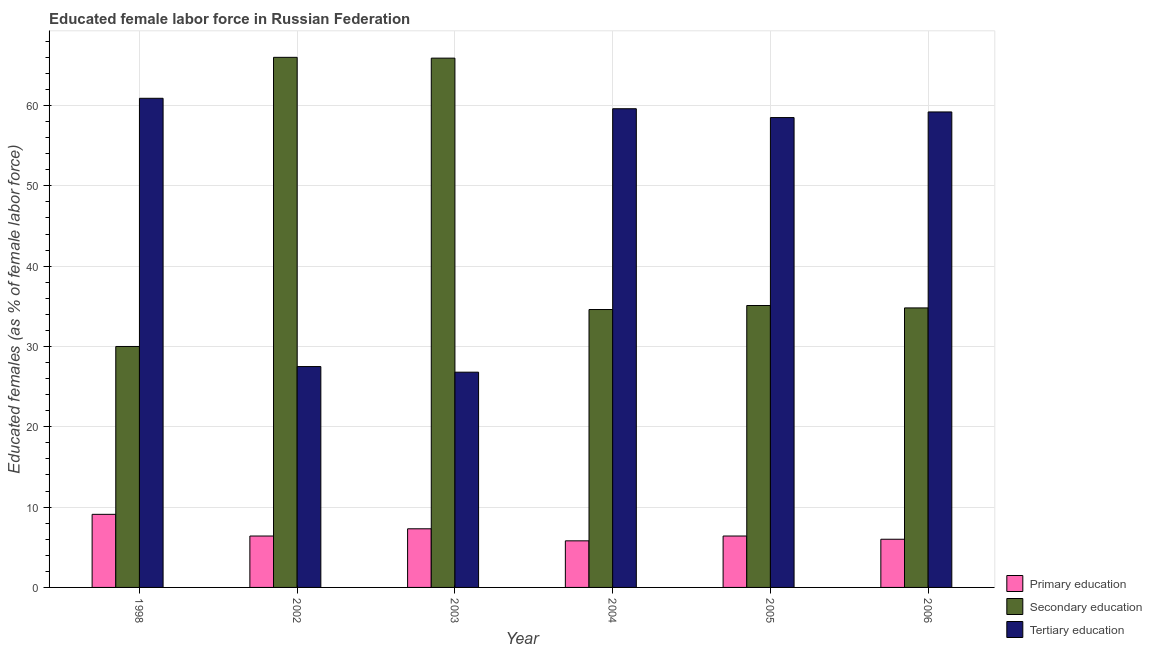How many groups of bars are there?
Make the answer very short. 6. Are the number of bars on each tick of the X-axis equal?
Keep it short and to the point. Yes. How many bars are there on the 4th tick from the left?
Make the answer very short. 3. What is the label of the 3rd group of bars from the left?
Your answer should be very brief. 2003. In how many cases, is the number of bars for a given year not equal to the number of legend labels?
Your response must be concise. 0. What is the percentage of female labor force who received primary education in 2006?
Offer a terse response. 6. Across all years, what is the maximum percentage of female labor force who received secondary education?
Provide a short and direct response. 66. In which year was the percentage of female labor force who received secondary education maximum?
Provide a succinct answer. 2002. What is the total percentage of female labor force who received secondary education in the graph?
Provide a succinct answer. 266.4. What is the difference between the percentage of female labor force who received tertiary education in 2006 and the percentage of female labor force who received secondary education in 2003?
Ensure brevity in your answer.  32.4. What is the average percentage of female labor force who received primary education per year?
Offer a very short reply. 6.83. What is the ratio of the percentage of female labor force who received secondary education in 2003 to that in 2006?
Offer a very short reply. 1.89. Is the percentage of female labor force who received secondary education in 1998 less than that in 2004?
Keep it short and to the point. Yes. What is the difference between the highest and the second highest percentage of female labor force who received primary education?
Give a very brief answer. 1.8. What is the difference between the highest and the lowest percentage of female labor force who received secondary education?
Keep it short and to the point. 36. What does the 3rd bar from the left in 2004 represents?
Keep it short and to the point. Tertiary education. What does the 1st bar from the right in 2006 represents?
Keep it short and to the point. Tertiary education. Is it the case that in every year, the sum of the percentage of female labor force who received primary education and percentage of female labor force who received secondary education is greater than the percentage of female labor force who received tertiary education?
Provide a short and direct response. No. How many bars are there?
Provide a short and direct response. 18. Are all the bars in the graph horizontal?
Provide a short and direct response. No. How many years are there in the graph?
Your answer should be very brief. 6. Does the graph contain grids?
Keep it short and to the point. Yes. Where does the legend appear in the graph?
Give a very brief answer. Bottom right. How are the legend labels stacked?
Provide a succinct answer. Vertical. What is the title of the graph?
Offer a very short reply. Educated female labor force in Russian Federation. What is the label or title of the X-axis?
Your answer should be very brief. Year. What is the label or title of the Y-axis?
Provide a succinct answer. Educated females (as % of female labor force). What is the Educated females (as % of female labor force) of Primary education in 1998?
Offer a terse response. 9.1. What is the Educated females (as % of female labor force) in Secondary education in 1998?
Provide a succinct answer. 30. What is the Educated females (as % of female labor force) in Tertiary education in 1998?
Provide a succinct answer. 60.9. What is the Educated females (as % of female labor force) of Primary education in 2002?
Provide a succinct answer. 6.4. What is the Educated females (as % of female labor force) in Secondary education in 2002?
Give a very brief answer. 66. What is the Educated females (as % of female labor force) in Primary education in 2003?
Offer a very short reply. 7.3. What is the Educated females (as % of female labor force) in Secondary education in 2003?
Keep it short and to the point. 65.9. What is the Educated females (as % of female labor force) in Tertiary education in 2003?
Make the answer very short. 26.8. What is the Educated females (as % of female labor force) in Primary education in 2004?
Keep it short and to the point. 5.8. What is the Educated females (as % of female labor force) in Secondary education in 2004?
Give a very brief answer. 34.6. What is the Educated females (as % of female labor force) in Tertiary education in 2004?
Your answer should be very brief. 59.6. What is the Educated females (as % of female labor force) of Primary education in 2005?
Offer a very short reply. 6.4. What is the Educated females (as % of female labor force) in Secondary education in 2005?
Make the answer very short. 35.1. What is the Educated females (as % of female labor force) of Tertiary education in 2005?
Keep it short and to the point. 58.5. What is the Educated females (as % of female labor force) of Primary education in 2006?
Offer a very short reply. 6. What is the Educated females (as % of female labor force) of Secondary education in 2006?
Provide a succinct answer. 34.8. What is the Educated females (as % of female labor force) of Tertiary education in 2006?
Give a very brief answer. 59.2. Across all years, what is the maximum Educated females (as % of female labor force) in Primary education?
Make the answer very short. 9.1. Across all years, what is the maximum Educated females (as % of female labor force) in Secondary education?
Keep it short and to the point. 66. Across all years, what is the maximum Educated females (as % of female labor force) of Tertiary education?
Give a very brief answer. 60.9. Across all years, what is the minimum Educated females (as % of female labor force) of Primary education?
Your response must be concise. 5.8. Across all years, what is the minimum Educated females (as % of female labor force) of Secondary education?
Offer a terse response. 30. Across all years, what is the minimum Educated females (as % of female labor force) in Tertiary education?
Offer a very short reply. 26.8. What is the total Educated females (as % of female labor force) of Secondary education in the graph?
Offer a terse response. 266.4. What is the total Educated females (as % of female labor force) of Tertiary education in the graph?
Make the answer very short. 292.5. What is the difference between the Educated females (as % of female labor force) in Primary education in 1998 and that in 2002?
Offer a terse response. 2.7. What is the difference between the Educated females (as % of female labor force) of Secondary education in 1998 and that in 2002?
Make the answer very short. -36. What is the difference between the Educated females (as % of female labor force) in Tertiary education in 1998 and that in 2002?
Provide a succinct answer. 33.4. What is the difference between the Educated females (as % of female labor force) in Secondary education in 1998 and that in 2003?
Your response must be concise. -35.9. What is the difference between the Educated females (as % of female labor force) of Tertiary education in 1998 and that in 2003?
Provide a succinct answer. 34.1. What is the difference between the Educated females (as % of female labor force) of Primary education in 1998 and that in 2004?
Give a very brief answer. 3.3. What is the difference between the Educated females (as % of female labor force) of Secondary education in 1998 and that in 2004?
Offer a very short reply. -4.6. What is the difference between the Educated females (as % of female labor force) of Tertiary education in 1998 and that in 2004?
Provide a succinct answer. 1.3. What is the difference between the Educated females (as % of female labor force) in Primary education in 1998 and that in 2005?
Keep it short and to the point. 2.7. What is the difference between the Educated females (as % of female labor force) in Primary education in 1998 and that in 2006?
Provide a succinct answer. 3.1. What is the difference between the Educated females (as % of female labor force) of Secondary education in 1998 and that in 2006?
Make the answer very short. -4.8. What is the difference between the Educated females (as % of female labor force) in Tertiary education in 1998 and that in 2006?
Provide a short and direct response. 1.7. What is the difference between the Educated females (as % of female labor force) of Primary education in 2002 and that in 2003?
Keep it short and to the point. -0.9. What is the difference between the Educated females (as % of female labor force) of Tertiary education in 2002 and that in 2003?
Your answer should be very brief. 0.7. What is the difference between the Educated females (as % of female labor force) in Secondary education in 2002 and that in 2004?
Give a very brief answer. 31.4. What is the difference between the Educated females (as % of female labor force) of Tertiary education in 2002 and that in 2004?
Your response must be concise. -32.1. What is the difference between the Educated females (as % of female labor force) of Secondary education in 2002 and that in 2005?
Ensure brevity in your answer.  30.9. What is the difference between the Educated females (as % of female labor force) of Tertiary education in 2002 and that in 2005?
Your response must be concise. -31. What is the difference between the Educated females (as % of female labor force) in Primary education in 2002 and that in 2006?
Ensure brevity in your answer.  0.4. What is the difference between the Educated females (as % of female labor force) of Secondary education in 2002 and that in 2006?
Your response must be concise. 31.2. What is the difference between the Educated females (as % of female labor force) in Tertiary education in 2002 and that in 2006?
Keep it short and to the point. -31.7. What is the difference between the Educated females (as % of female labor force) in Primary education in 2003 and that in 2004?
Offer a terse response. 1.5. What is the difference between the Educated females (as % of female labor force) of Secondary education in 2003 and that in 2004?
Offer a very short reply. 31.3. What is the difference between the Educated females (as % of female labor force) in Tertiary education in 2003 and that in 2004?
Your answer should be compact. -32.8. What is the difference between the Educated females (as % of female labor force) of Secondary education in 2003 and that in 2005?
Give a very brief answer. 30.8. What is the difference between the Educated females (as % of female labor force) of Tertiary education in 2003 and that in 2005?
Your answer should be very brief. -31.7. What is the difference between the Educated females (as % of female labor force) of Primary education in 2003 and that in 2006?
Your answer should be compact. 1.3. What is the difference between the Educated females (as % of female labor force) in Secondary education in 2003 and that in 2006?
Make the answer very short. 31.1. What is the difference between the Educated females (as % of female labor force) of Tertiary education in 2003 and that in 2006?
Your answer should be compact. -32.4. What is the difference between the Educated females (as % of female labor force) of Primary education in 2004 and that in 2005?
Your response must be concise. -0.6. What is the difference between the Educated females (as % of female labor force) in Secondary education in 2004 and that in 2005?
Your answer should be very brief. -0.5. What is the difference between the Educated females (as % of female labor force) in Tertiary education in 2004 and that in 2005?
Give a very brief answer. 1.1. What is the difference between the Educated females (as % of female labor force) in Primary education in 2004 and that in 2006?
Provide a succinct answer. -0.2. What is the difference between the Educated females (as % of female labor force) in Secondary education in 2004 and that in 2006?
Your response must be concise. -0.2. What is the difference between the Educated females (as % of female labor force) of Tertiary education in 2004 and that in 2006?
Offer a terse response. 0.4. What is the difference between the Educated females (as % of female labor force) of Secondary education in 2005 and that in 2006?
Provide a short and direct response. 0.3. What is the difference between the Educated females (as % of female labor force) of Tertiary education in 2005 and that in 2006?
Offer a very short reply. -0.7. What is the difference between the Educated females (as % of female labor force) in Primary education in 1998 and the Educated females (as % of female labor force) in Secondary education in 2002?
Your response must be concise. -56.9. What is the difference between the Educated females (as % of female labor force) in Primary education in 1998 and the Educated females (as % of female labor force) in Tertiary education in 2002?
Your response must be concise. -18.4. What is the difference between the Educated females (as % of female labor force) of Primary education in 1998 and the Educated females (as % of female labor force) of Secondary education in 2003?
Your response must be concise. -56.8. What is the difference between the Educated females (as % of female labor force) in Primary education in 1998 and the Educated females (as % of female labor force) in Tertiary education in 2003?
Offer a very short reply. -17.7. What is the difference between the Educated females (as % of female labor force) in Primary education in 1998 and the Educated females (as % of female labor force) in Secondary education in 2004?
Offer a very short reply. -25.5. What is the difference between the Educated females (as % of female labor force) in Primary education in 1998 and the Educated females (as % of female labor force) in Tertiary education in 2004?
Offer a terse response. -50.5. What is the difference between the Educated females (as % of female labor force) of Secondary education in 1998 and the Educated females (as % of female labor force) of Tertiary education in 2004?
Provide a succinct answer. -29.6. What is the difference between the Educated females (as % of female labor force) in Primary education in 1998 and the Educated females (as % of female labor force) in Secondary education in 2005?
Provide a short and direct response. -26. What is the difference between the Educated females (as % of female labor force) in Primary education in 1998 and the Educated females (as % of female labor force) in Tertiary education in 2005?
Offer a terse response. -49.4. What is the difference between the Educated females (as % of female labor force) of Secondary education in 1998 and the Educated females (as % of female labor force) of Tertiary education in 2005?
Provide a succinct answer. -28.5. What is the difference between the Educated females (as % of female labor force) of Primary education in 1998 and the Educated females (as % of female labor force) of Secondary education in 2006?
Make the answer very short. -25.7. What is the difference between the Educated females (as % of female labor force) of Primary education in 1998 and the Educated females (as % of female labor force) of Tertiary education in 2006?
Give a very brief answer. -50.1. What is the difference between the Educated females (as % of female labor force) in Secondary education in 1998 and the Educated females (as % of female labor force) in Tertiary education in 2006?
Provide a succinct answer. -29.2. What is the difference between the Educated females (as % of female labor force) in Primary education in 2002 and the Educated females (as % of female labor force) in Secondary education in 2003?
Provide a short and direct response. -59.5. What is the difference between the Educated females (as % of female labor force) of Primary education in 2002 and the Educated females (as % of female labor force) of Tertiary education in 2003?
Make the answer very short. -20.4. What is the difference between the Educated females (as % of female labor force) in Secondary education in 2002 and the Educated females (as % of female labor force) in Tertiary education in 2003?
Your response must be concise. 39.2. What is the difference between the Educated females (as % of female labor force) in Primary education in 2002 and the Educated females (as % of female labor force) in Secondary education in 2004?
Provide a short and direct response. -28.2. What is the difference between the Educated females (as % of female labor force) of Primary education in 2002 and the Educated females (as % of female labor force) of Tertiary education in 2004?
Your answer should be compact. -53.2. What is the difference between the Educated females (as % of female labor force) of Secondary education in 2002 and the Educated females (as % of female labor force) of Tertiary education in 2004?
Offer a terse response. 6.4. What is the difference between the Educated females (as % of female labor force) of Primary education in 2002 and the Educated females (as % of female labor force) of Secondary education in 2005?
Provide a succinct answer. -28.7. What is the difference between the Educated females (as % of female labor force) in Primary education in 2002 and the Educated females (as % of female labor force) in Tertiary education in 2005?
Make the answer very short. -52.1. What is the difference between the Educated females (as % of female labor force) of Primary education in 2002 and the Educated females (as % of female labor force) of Secondary education in 2006?
Offer a terse response. -28.4. What is the difference between the Educated females (as % of female labor force) of Primary education in 2002 and the Educated females (as % of female labor force) of Tertiary education in 2006?
Your response must be concise. -52.8. What is the difference between the Educated females (as % of female labor force) of Primary education in 2003 and the Educated females (as % of female labor force) of Secondary education in 2004?
Offer a very short reply. -27.3. What is the difference between the Educated females (as % of female labor force) of Primary education in 2003 and the Educated females (as % of female labor force) of Tertiary education in 2004?
Provide a short and direct response. -52.3. What is the difference between the Educated females (as % of female labor force) of Primary education in 2003 and the Educated females (as % of female labor force) of Secondary education in 2005?
Provide a short and direct response. -27.8. What is the difference between the Educated females (as % of female labor force) in Primary education in 2003 and the Educated females (as % of female labor force) in Tertiary education in 2005?
Your answer should be very brief. -51.2. What is the difference between the Educated females (as % of female labor force) in Secondary education in 2003 and the Educated females (as % of female labor force) in Tertiary education in 2005?
Your answer should be very brief. 7.4. What is the difference between the Educated females (as % of female labor force) in Primary education in 2003 and the Educated females (as % of female labor force) in Secondary education in 2006?
Make the answer very short. -27.5. What is the difference between the Educated females (as % of female labor force) of Primary education in 2003 and the Educated females (as % of female labor force) of Tertiary education in 2006?
Make the answer very short. -51.9. What is the difference between the Educated females (as % of female labor force) of Primary education in 2004 and the Educated females (as % of female labor force) of Secondary education in 2005?
Offer a very short reply. -29.3. What is the difference between the Educated females (as % of female labor force) of Primary education in 2004 and the Educated females (as % of female labor force) of Tertiary education in 2005?
Provide a succinct answer. -52.7. What is the difference between the Educated females (as % of female labor force) of Secondary education in 2004 and the Educated females (as % of female labor force) of Tertiary education in 2005?
Give a very brief answer. -23.9. What is the difference between the Educated females (as % of female labor force) in Primary education in 2004 and the Educated females (as % of female labor force) in Tertiary education in 2006?
Your answer should be compact. -53.4. What is the difference between the Educated females (as % of female labor force) of Secondary education in 2004 and the Educated females (as % of female labor force) of Tertiary education in 2006?
Ensure brevity in your answer.  -24.6. What is the difference between the Educated females (as % of female labor force) of Primary education in 2005 and the Educated females (as % of female labor force) of Secondary education in 2006?
Offer a very short reply. -28.4. What is the difference between the Educated females (as % of female labor force) in Primary education in 2005 and the Educated females (as % of female labor force) in Tertiary education in 2006?
Offer a terse response. -52.8. What is the difference between the Educated females (as % of female labor force) of Secondary education in 2005 and the Educated females (as % of female labor force) of Tertiary education in 2006?
Offer a very short reply. -24.1. What is the average Educated females (as % of female labor force) of Primary education per year?
Keep it short and to the point. 6.83. What is the average Educated females (as % of female labor force) of Secondary education per year?
Your response must be concise. 44.4. What is the average Educated females (as % of female labor force) in Tertiary education per year?
Provide a short and direct response. 48.75. In the year 1998, what is the difference between the Educated females (as % of female labor force) in Primary education and Educated females (as % of female labor force) in Secondary education?
Keep it short and to the point. -20.9. In the year 1998, what is the difference between the Educated females (as % of female labor force) of Primary education and Educated females (as % of female labor force) of Tertiary education?
Your response must be concise. -51.8. In the year 1998, what is the difference between the Educated females (as % of female labor force) in Secondary education and Educated females (as % of female labor force) in Tertiary education?
Keep it short and to the point. -30.9. In the year 2002, what is the difference between the Educated females (as % of female labor force) of Primary education and Educated females (as % of female labor force) of Secondary education?
Provide a succinct answer. -59.6. In the year 2002, what is the difference between the Educated females (as % of female labor force) of Primary education and Educated females (as % of female labor force) of Tertiary education?
Make the answer very short. -21.1. In the year 2002, what is the difference between the Educated females (as % of female labor force) in Secondary education and Educated females (as % of female labor force) in Tertiary education?
Offer a very short reply. 38.5. In the year 2003, what is the difference between the Educated females (as % of female labor force) of Primary education and Educated females (as % of female labor force) of Secondary education?
Your answer should be very brief. -58.6. In the year 2003, what is the difference between the Educated females (as % of female labor force) in Primary education and Educated females (as % of female labor force) in Tertiary education?
Make the answer very short. -19.5. In the year 2003, what is the difference between the Educated females (as % of female labor force) of Secondary education and Educated females (as % of female labor force) of Tertiary education?
Provide a succinct answer. 39.1. In the year 2004, what is the difference between the Educated females (as % of female labor force) of Primary education and Educated females (as % of female labor force) of Secondary education?
Your answer should be compact. -28.8. In the year 2004, what is the difference between the Educated females (as % of female labor force) in Primary education and Educated females (as % of female labor force) in Tertiary education?
Ensure brevity in your answer.  -53.8. In the year 2005, what is the difference between the Educated females (as % of female labor force) in Primary education and Educated females (as % of female labor force) in Secondary education?
Your answer should be very brief. -28.7. In the year 2005, what is the difference between the Educated females (as % of female labor force) of Primary education and Educated females (as % of female labor force) of Tertiary education?
Your response must be concise. -52.1. In the year 2005, what is the difference between the Educated females (as % of female labor force) in Secondary education and Educated females (as % of female labor force) in Tertiary education?
Provide a succinct answer. -23.4. In the year 2006, what is the difference between the Educated females (as % of female labor force) of Primary education and Educated females (as % of female labor force) of Secondary education?
Your answer should be very brief. -28.8. In the year 2006, what is the difference between the Educated females (as % of female labor force) of Primary education and Educated females (as % of female labor force) of Tertiary education?
Make the answer very short. -53.2. In the year 2006, what is the difference between the Educated females (as % of female labor force) of Secondary education and Educated females (as % of female labor force) of Tertiary education?
Make the answer very short. -24.4. What is the ratio of the Educated females (as % of female labor force) of Primary education in 1998 to that in 2002?
Offer a very short reply. 1.42. What is the ratio of the Educated females (as % of female labor force) of Secondary education in 1998 to that in 2002?
Give a very brief answer. 0.45. What is the ratio of the Educated females (as % of female labor force) of Tertiary education in 1998 to that in 2002?
Offer a terse response. 2.21. What is the ratio of the Educated females (as % of female labor force) in Primary education in 1998 to that in 2003?
Keep it short and to the point. 1.25. What is the ratio of the Educated females (as % of female labor force) in Secondary education in 1998 to that in 2003?
Your response must be concise. 0.46. What is the ratio of the Educated females (as % of female labor force) in Tertiary education in 1998 to that in 2003?
Provide a short and direct response. 2.27. What is the ratio of the Educated females (as % of female labor force) of Primary education in 1998 to that in 2004?
Keep it short and to the point. 1.57. What is the ratio of the Educated females (as % of female labor force) of Secondary education in 1998 to that in 2004?
Make the answer very short. 0.87. What is the ratio of the Educated females (as % of female labor force) of Tertiary education in 1998 to that in 2004?
Offer a terse response. 1.02. What is the ratio of the Educated females (as % of female labor force) of Primary education in 1998 to that in 2005?
Provide a succinct answer. 1.42. What is the ratio of the Educated females (as % of female labor force) in Secondary education in 1998 to that in 2005?
Your answer should be compact. 0.85. What is the ratio of the Educated females (as % of female labor force) in Tertiary education in 1998 to that in 2005?
Provide a succinct answer. 1.04. What is the ratio of the Educated females (as % of female labor force) of Primary education in 1998 to that in 2006?
Your response must be concise. 1.52. What is the ratio of the Educated females (as % of female labor force) of Secondary education in 1998 to that in 2006?
Ensure brevity in your answer.  0.86. What is the ratio of the Educated females (as % of female labor force) of Tertiary education in 1998 to that in 2006?
Provide a short and direct response. 1.03. What is the ratio of the Educated females (as % of female labor force) of Primary education in 2002 to that in 2003?
Provide a succinct answer. 0.88. What is the ratio of the Educated females (as % of female labor force) in Tertiary education in 2002 to that in 2003?
Your response must be concise. 1.03. What is the ratio of the Educated females (as % of female labor force) in Primary education in 2002 to that in 2004?
Provide a succinct answer. 1.1. What is the ratio of the Educated females (as % of female labor force) in Secondary education in 2002 to that in 2004?
Your response must be concise. 1.91. What is the ratio of the Educated females (as % of female labor force) of Tertiary education in 2002 to that in 2004?
Keep it short and to the point. 0.46. What is the ratio of the Educated females (as % of female labor force) of Secondary education in 2002 to that in 2005?
Make the answer very short. 1.88. What is the ratio of the Educated females (as % of female labor force) of Tertiary education in 2002 to that in 2005?
Your answer should be very brief. 0.47. What is the ratio of the Educated females (as % of female labor force) in Primary education in 2002 to that in 2006?
Make the answer very short. 1.07. What is the ratio of the Educated females (as % of female labor force) in Secondary education in 2002 to that in 2006?
Offer a very short reply. 1.9. What is the ratio of the Educated females (as % of female labor force) of Tertiary education in 2002 to that in 2006?
Ensure brevity in your answer.  0.46. What is the ratio of the Educated females (as % of female labor force) of Primary education in 2003 to that in 2004?
Make the answer very short. 1.26. What is the ratio of the Educated females (as % of female labor force) of Secondary education in 2003 to that in 2004?
Your answer should be compact. 1.9. What is the ratio of the Educated females (as % of female labor force) of Tertiary education in 2003 to that in 2004?
Your response must be concise. 0.45. What is the ratio of the Educated females (as % of female labor force) of Primary education in 2003 to that in 2005?
Ensure brevity in your answer.  1.14. What is the ratio of the Educated females (as % of female labor force) in Secondary education in 2003 to that in 2005?
Keep it short and to the point. 1.88. What is the ratio of the Educated females (as % of female labor force) of Tertiary education in 2003 to that in 2005?
Offer a very short reply. 0.46. What is the ratio of the Educated females (as % of female labor force) of Primary education in 2003 to that in 2006?
Offer a terse response. 1.22. What is the ratio of the Educated females (as % of female labor force) in Secondary education in 2003 to that in 2006?
Make the answer very short. 1.89. What is the ratio of the Educated females (as % of female labor force) of Tertiary education in 2003 to that in 2006?
Offer a terse response. 0.45. What is the ratio of the Educated females (as % of female labor force) of Primary education in 2004 to that in 2005?
Provide a succinct answer. 0.91. What is the ratio of the Educated females (as % of female labor force) of Secondary education in 2004 to that in 2005?
Your answer should be compact. 0.99. What is the ratio of the Educated females (as % of female labor force) in Tertiary education in 2004 to that in 2005?
Your answer should be very brief. 1.02. What is the ratio of the Educated females (as % of female labor force) of Primary education in 2004 to that in 2006?
Ensure brevity in your answer.  0.97. What is the ratio of the Educated females (as % of female labor force) in Secondary education in 2004 to that in 2006?
Ensure brevity in your answer.  0.99. What is the ratio of the Educated females (as % of female labor force) in Tertiary education in 2004 to that in 2006?
Offer a very short reply. 1.01. What is the ratio of the Educated females (as % of female labor force) of Primary education in 2005 to that in 2006?
Provide a succinct answer. 1.07. What is the ratio of the Educated females (as % of female labor force) in Secondary education in 2005 to that in 2006?
Your answer should be compact. 1.01. What is the difference between the highest and the second highest Educated females (as % of female labor force) in Primary education?
Give a very brief answer. 1.8. What is the difference between the highest and the second highest Educated females (as % of female labor force) of Secondary education?
Provide a short and direct response. 0.1. What is the difference between the highest and the second highest Educated females (as % of female labor force) of Tertiary education?
Your response must be concise. 1.3. What is the difference between the highest and the lowest Educated females (as % of female labor force) of Primary education?
Your answer should be very brief. 3.3. What is the difference between the highest and the lowest Educated females (as % of female labor force) of Secondary education?
Your response must be concise. 36. What is the difference between the highest and the lowest Educated females (as % of female labor force) in Tertiary education?
Your response must be concise. 34.1. 